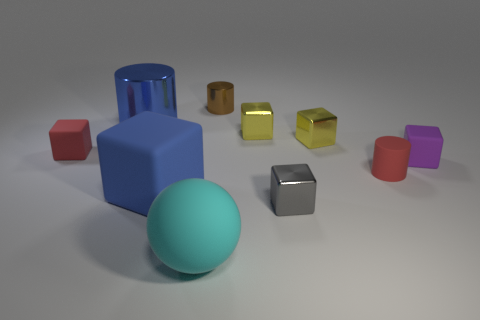Subtract all red cubes. How many cubes are left? 5 Subtract all purple rubber cubes. How many cubes are left? 5 Subtract all brown cylinders. Subtract all yellow blocks. How many cylinders are left? 2 Subtract all balls. How many objects are left? 9 Subtract 0 cyan cubes. How many objects are left? 10 Subtract all tiny matte balls. Subtract all blue metallic things. How many objects are left? 9 Add 8 gray shiny things. How many gray shiny things are left? 9 Add 6 tiny purple shiny balls. How many tiny purple shiny balls exist? 6 